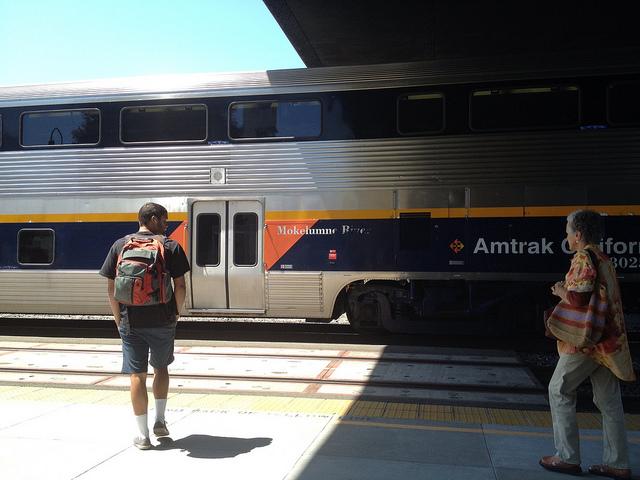What train company is this?
Short answer required. Amtrak. Is she about to fall?
Short answer required. No. Is it a hot day?
Keep it brief. Yes. What color is the boy's coat?
Be succinct. No coat. How many levels are on the train?
Answer briefly. 2. On what side of the man is the sun?
Keep it brief. Left. What is the boy doing in the photo?
Give a very brief answer. Walking. 